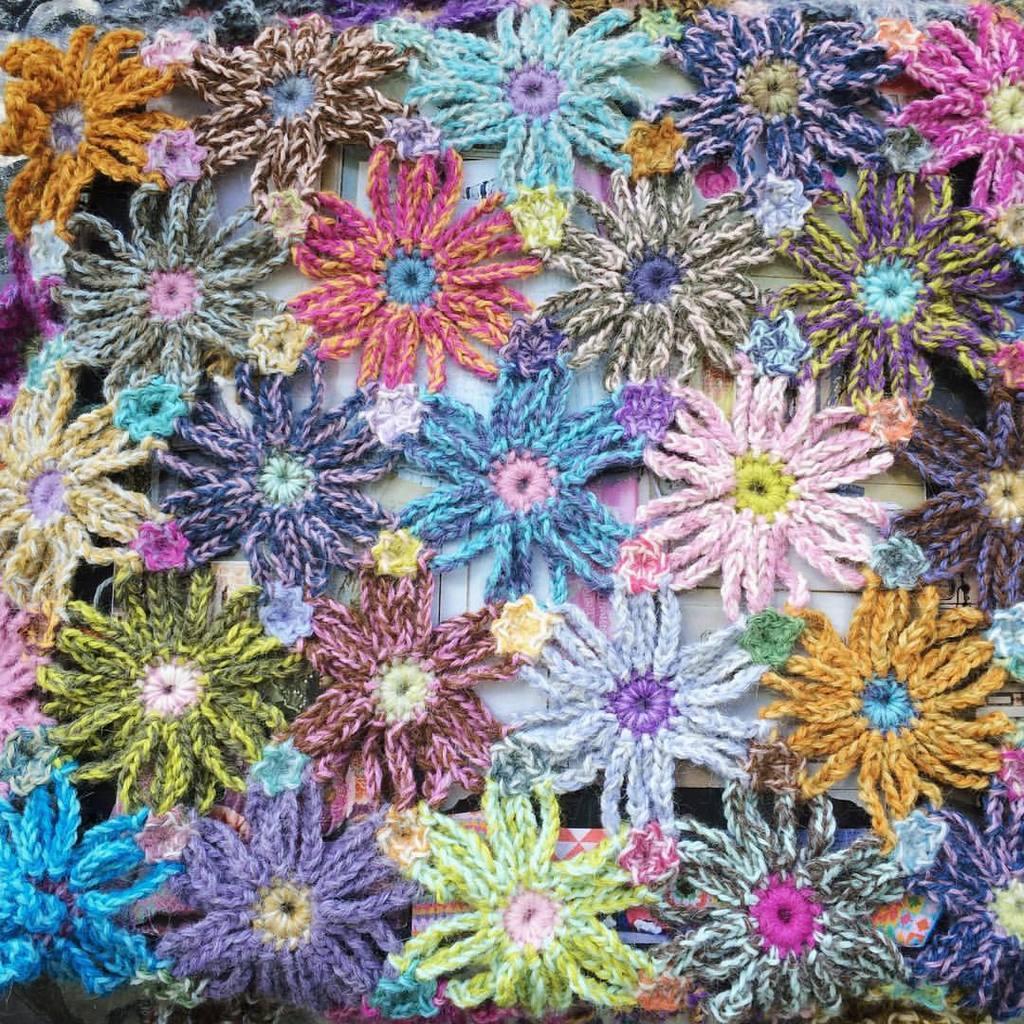Please provide a concise description of this image. In this image I can see woolen flowers. 